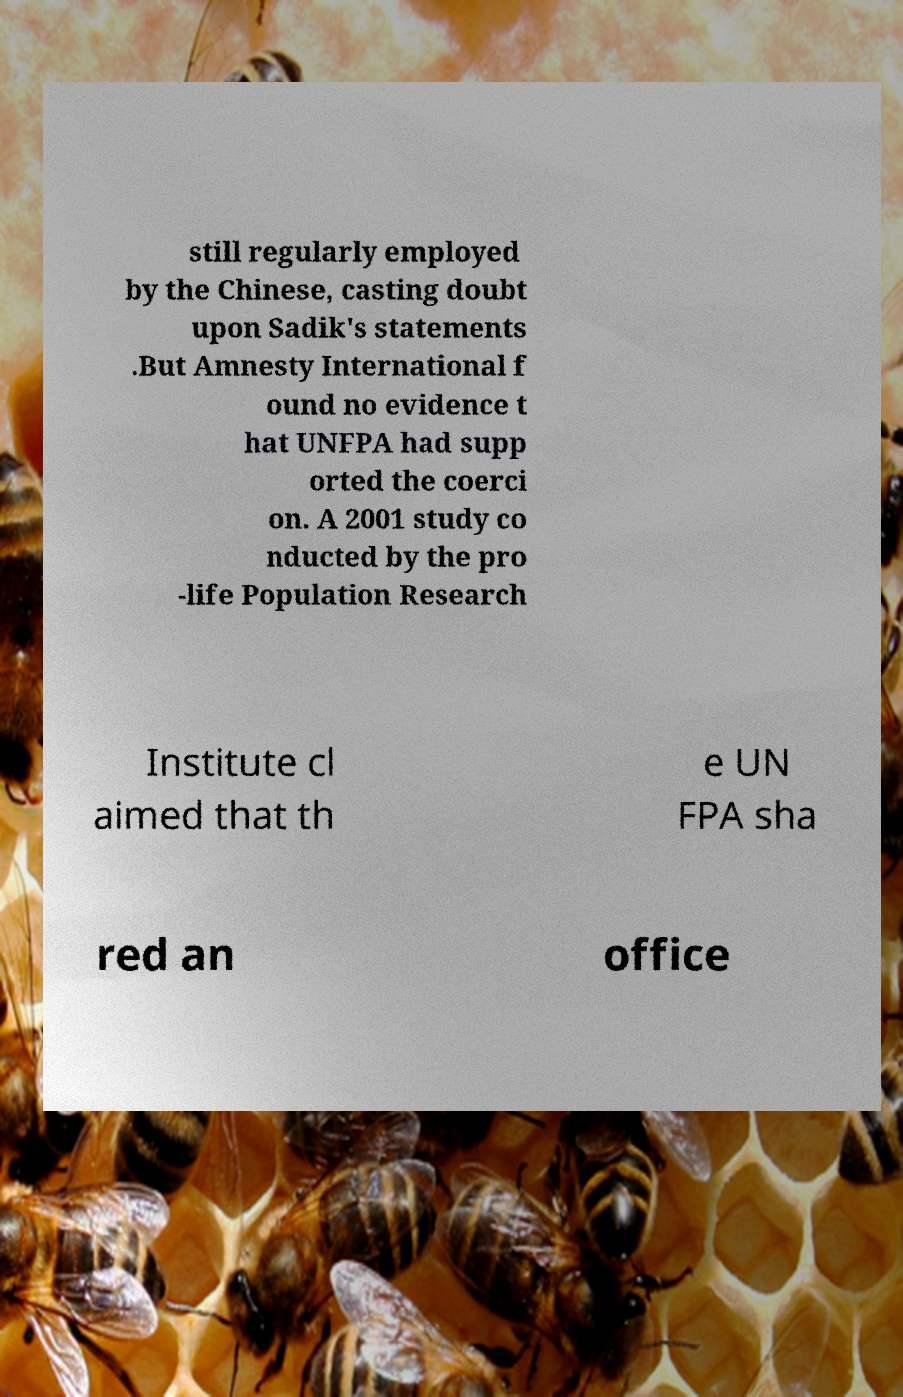I need the written content from this picture converted into text. Can you do that? still regularly employed by the Chinese, casting doubt upon Sadik's statements .But Amnesty International f ound no evidence t hat UNFPA had supp orted the coerci on. A 2001 study co nducted by the pro -life Population Research Institute cl aimed that th e UN FPA sha red an office 